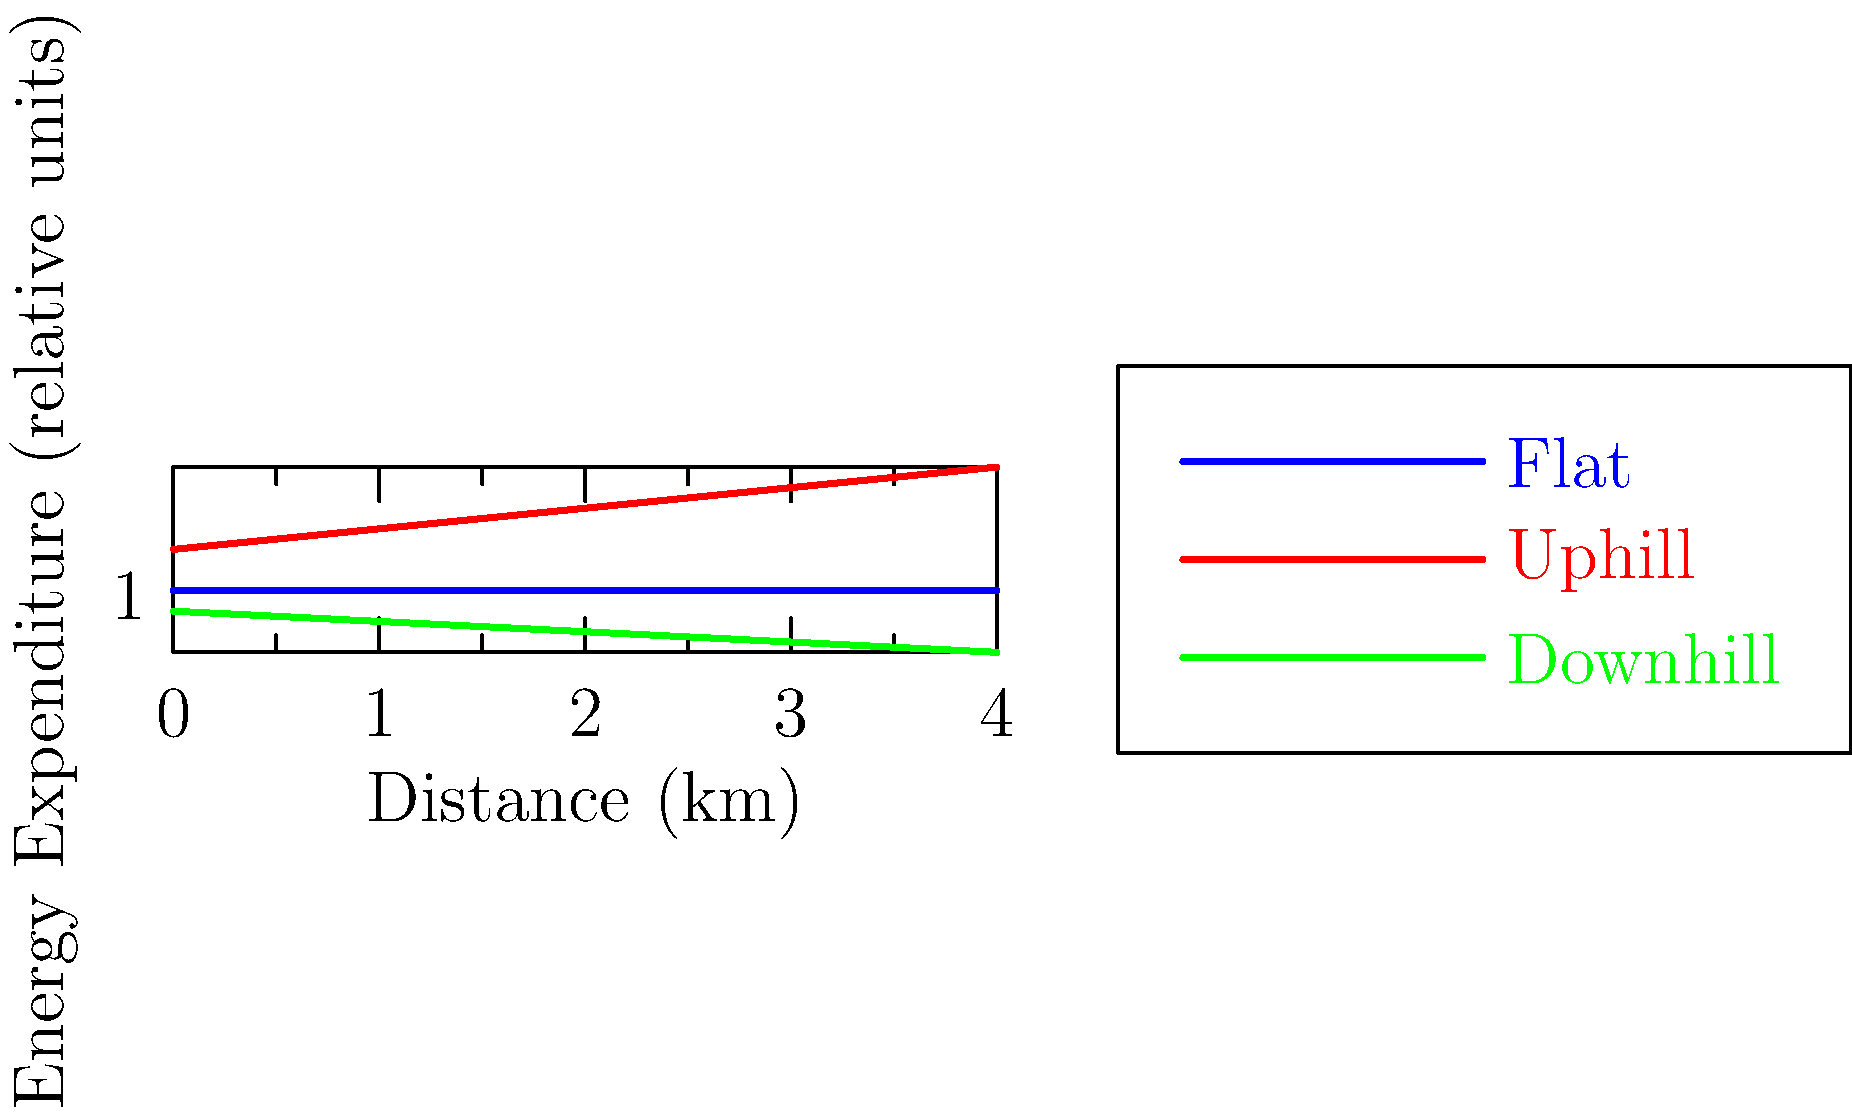As an experienced adventurer leading a wilderness expedition, you're analyzing the energy expenditure of your team during different terrain conditions. The graph shows relative energy expenditure over distance for flat, uphill, and downhill terrains. If your team needs to cover a 10 km distance with minimal energy expenditure, and the terrain options are 5 km flat followed by 5 km uphill, or 5 km downhill followed by 5 km flat, which option should you choose? Assume the slopes and energy expenditure rates remain constant as shown in the graph. To solve this problem, we need to calculate and compare the total energy expenditure for both options:

Option 1: 5 km flat + 5 km uphill
Option 2: 5 km downhill + 5 km flat

Step 1: Calculate energy expenditure for Option 1
- Flat terrain (0-5 km): 5 * 1 = 5 units
- Uphill terrain (5-10 km): 5 * 1.4 = 7 units (using the average value from the graph)
- Total for Option 1: 5 + 7 = 12 units

Step 2: Calculate energy expenditure for Option 2
- Downhill terrain (0-5 km): 5 * 0.8 = 4 units (using the average value from the graph)
- Flat terrain (5-10 km): 5 * 1 = 5 units
- Total for Option 2: 4 + 5 = 9 units

Step 3: Compare the results
Option 2 (9 units) requires less energy than Option 1 (12 units).

Therefore, to minimize energy expenditure, you should choose the route with 5 km downhill followed by 5 km flat terrain.
Answer: 5 km downhill + 5 km flat 